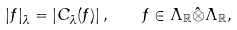<formula> <loc_0><loc_0><loc_500><loc_500>| f | _ { \bar { \lambda } } = \left | C _ { \bar { \lambda } } ( f ) \right | , \quad f \in \Lambda _ { \mathbb { R } } \hat { \otimes } \Lambda _ { \mathbb { R } } ,</formula> 